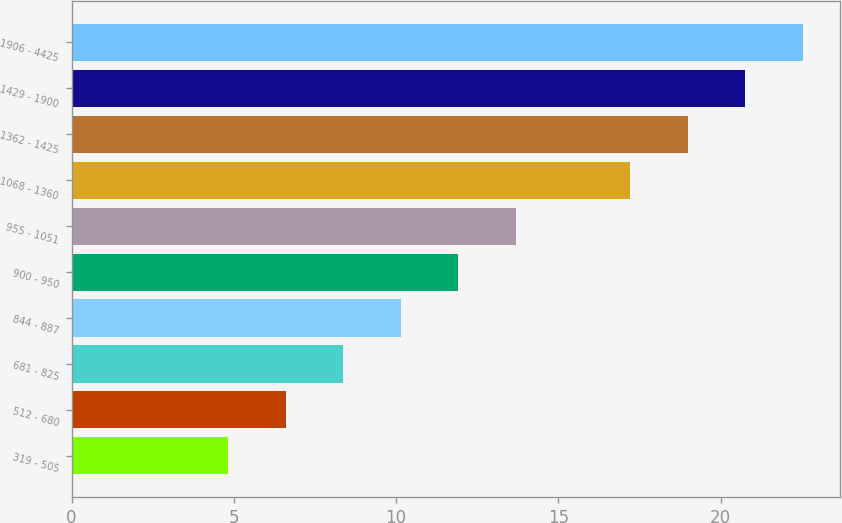Convert chart to OTSL. <chart><loc_0><loc_0><loc_500><loc_500><bar_chart><fcel>319 - 505<fcel>512 - 680<fcel>681 - 825<fcel>844 - 887<fcel>900 - 950<fcel>955 - 1051<fcel>1068 - 1360<fcel>1362 - 1425<fcel>1429 - 1900<fcel>1906 - 4425<nl><fcel>4.83<fcel>6.6<fcel>8.37<fcel>10.14<fcel>11.91<fcel>13.68<fcel>17.22<fcel>18.99<fcel>20.76<fcel>22.54<nl></chart> 